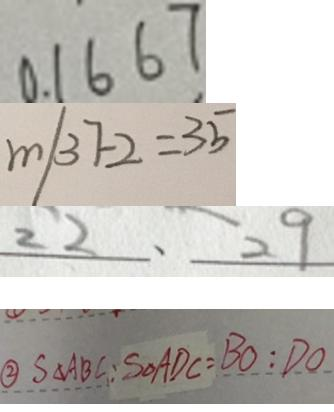Convert formula to latex. <formula><loc_0><loc_0><loc_500><loc_500>0 . 1 6 6 7 
 m / 3 7 - 2 = 3 5 
 2 2 、 2 9 
 \textcircled { 2 } S _ { \Delta } A B C : S _ { \Delta } A D C = B O : D O</formula> 